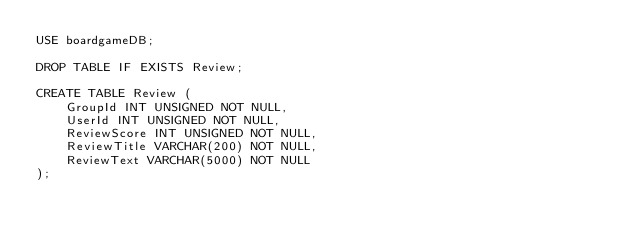<code> <loc_0><loc_0><loc_500><loc_500><_SQL_>USE boardgameDB;

DROP TABLE IF EXISTS Review;

CREATE TABLE Review (
	GroupId INT UNSIGNED NOT NULL,
    UserId INT UNSIGNED NOT NULL,
    ReviewScore INT UNSIGNED NOT NULL,
    ReviewTitle VARCHAR(200) NOT NULL,
    ReviewText VARCHAR(5000) NOT NULL
);</code> 